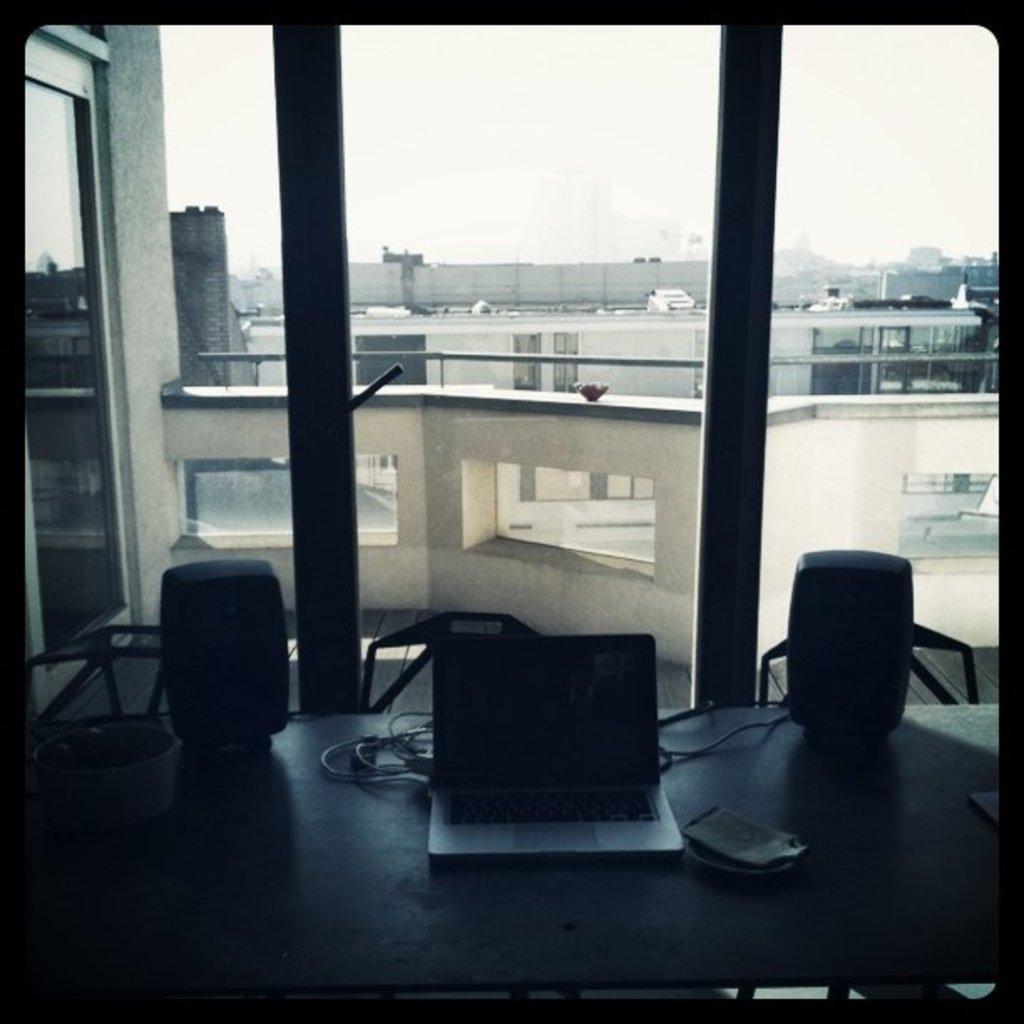Can you describe this image briefly? We can see glass window,table and chairs. On the table we can see laptop,cable and things. From this glass window we can see buildings and sky. 